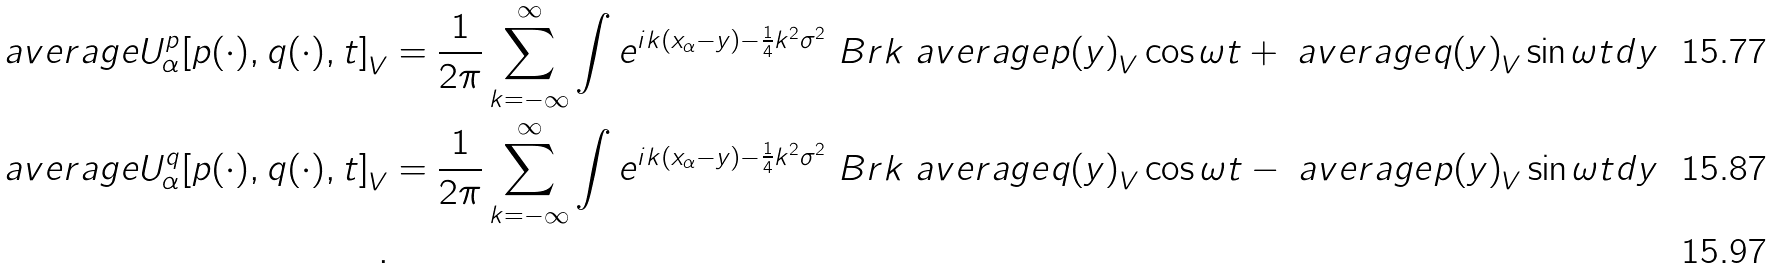<formula> <loc_0><loc_0><loc_500><loc_500>\ a v e r a g e { U ^ { p } _ { \alpha } [ p ( \cdot ) , q ( \cdot ) , t ] } _ { V } & = \frac { 1 } { 2 \pi } \sum _ { k = - \infty } ^ { \infty } \int e ^ { i k ( x _ { \alpha } - y ) - \frac { 1 } { 4 } k ^ { 2 } \sigma ^ { 2 } } \ B r k { \ a v e r a g e { p ( y ) } _ { V } \cos \omega t + \ a v e r a g e { q ( y ) } _ { V } \sin \omega t } d y \\ \ a v e r a g e { U ^ { q } _ { \alpha } [ p ( \cdot ) , q ( \cdot ) , t ] } _ { V } & = \frac { 1 } { 2 \pi } \sum _ { k = - \infty } ^ { \infty } \int e ^ { i k ( x _ { \alpha } - y ) - \frac { 1 } { 4 } k ^ { 2 } \sigma ^ { 2 } } \ B r k { \ a v e r a g e { q ( y ) } _ { V } \cos \omega t - \ a v e r a g e { p ( y ) } _ { V } \sin \omega t } d y \\ .</formula> 